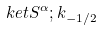Convert formula to latex. <formula><loc_0><loc_0><loc_500><loc_500>\ k e t { S ^ { \alpha } ; k } _ { - 1 / 2 }</formula> 